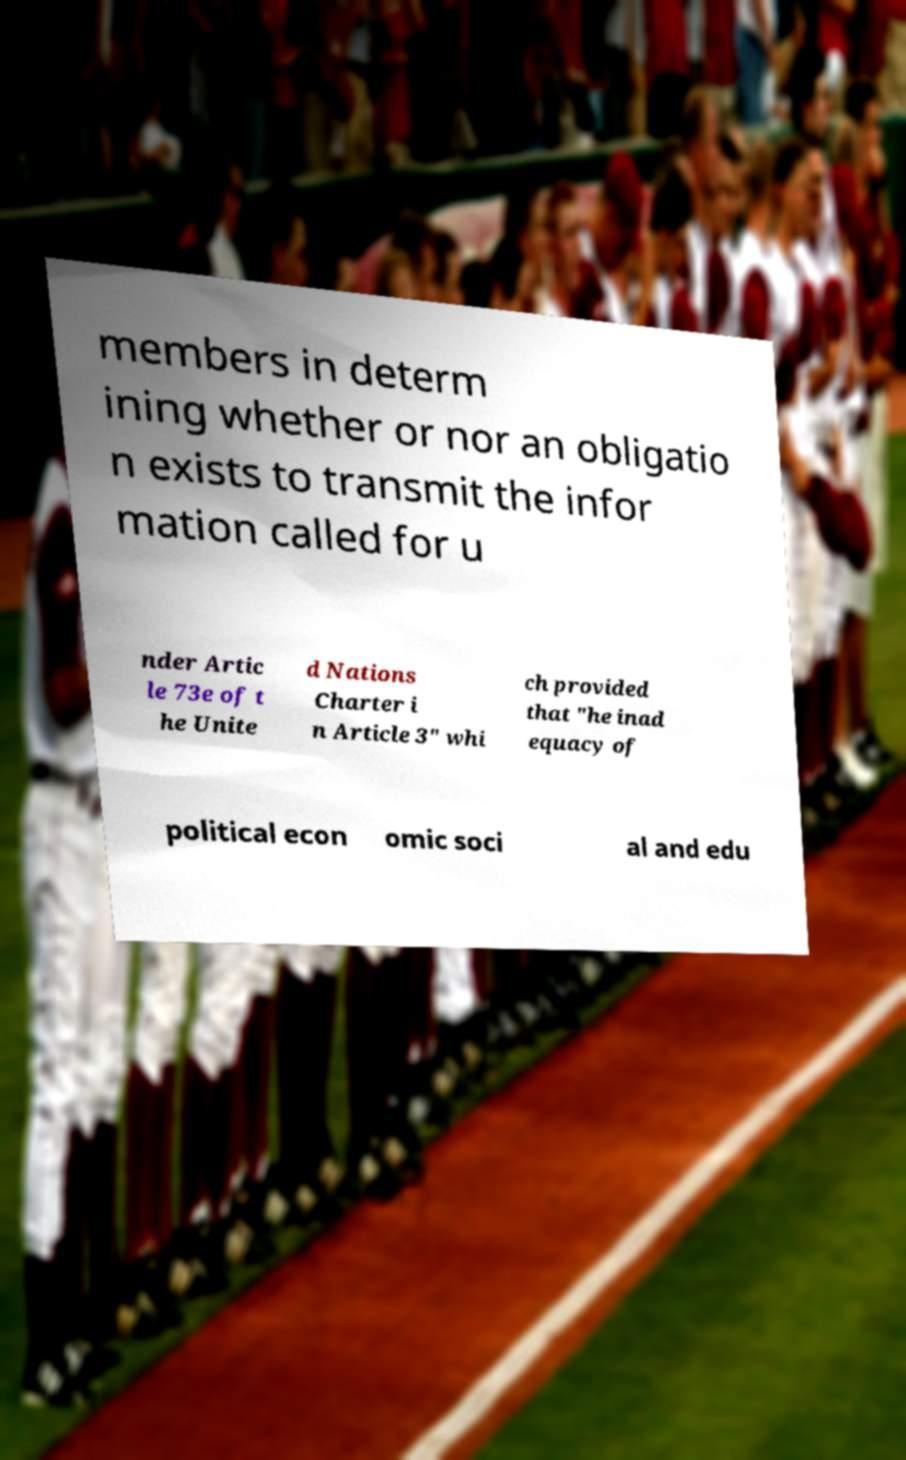Can you read and provide the text displayed in the image?This photo seems to have some interesting text. Can you extract and type it out for me? members in determ ining whether or nor an obligatio n exists to transmit the infor mation called for u nder Artic le 73e of t he Unite d Nations Charter i n Article 3" whi ch provided that "he inad equacy of political econ omic soci al and edu 